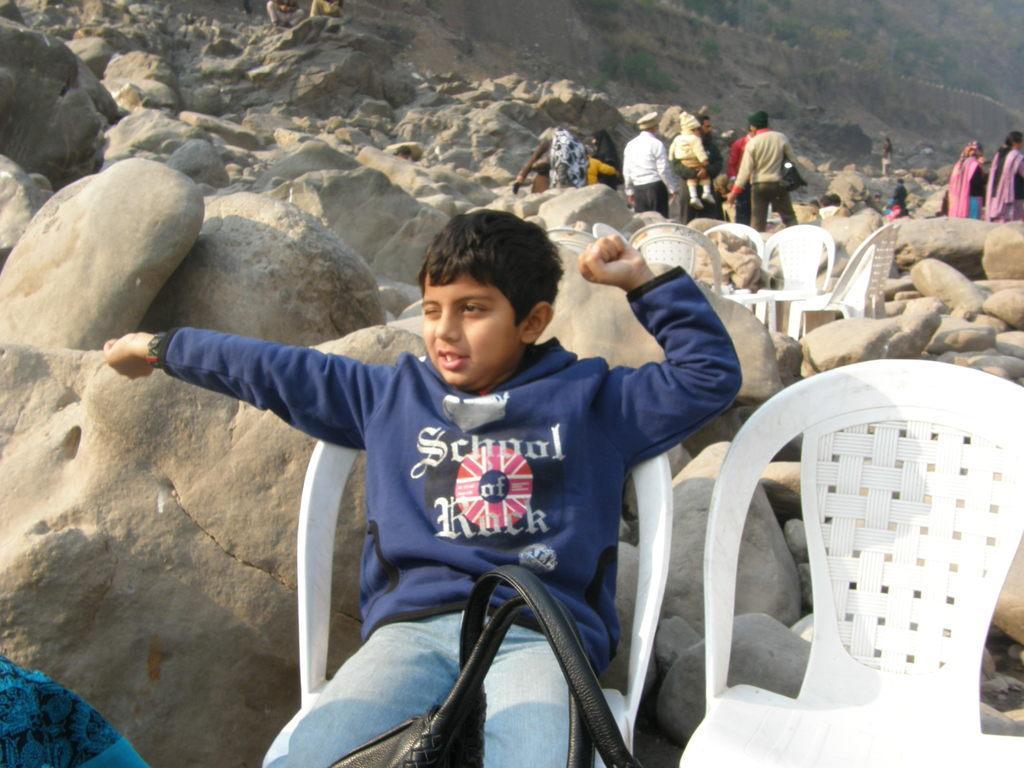Describe this image in one or two sentences. In this image I can see the person sitting on the white chair. In the background I can see many rocks, chairs and the group of people with different color dresses. I can also see the mountains and trees in the back. 